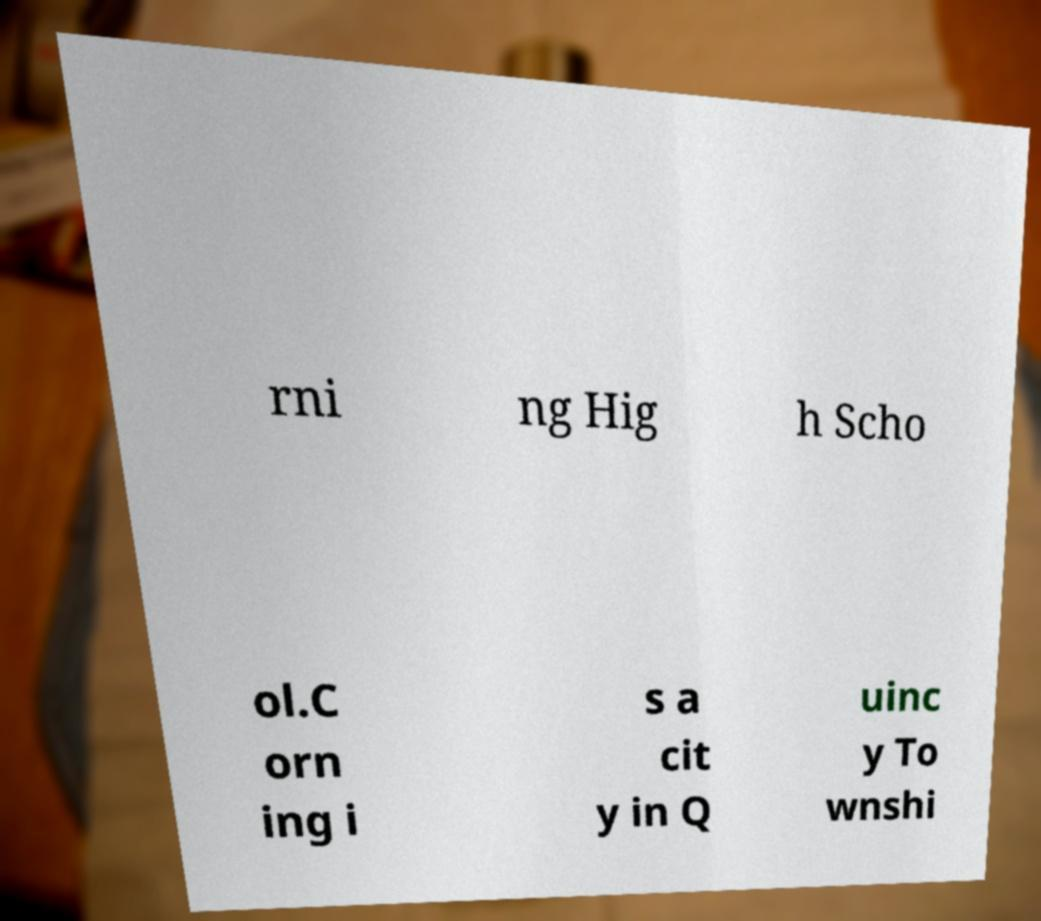There's text embedded in this image that I need extracted. Can you transcribe it verbatim? rni ng Hig h Scho ol.C orn ing i s a cit y in Q uinc y To wnshi 